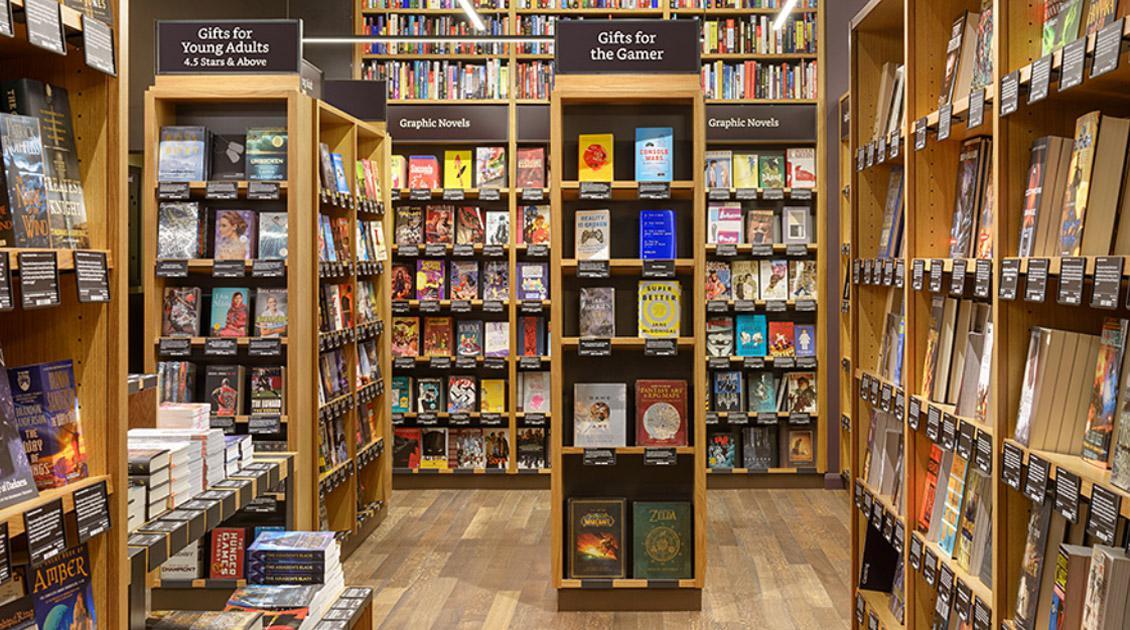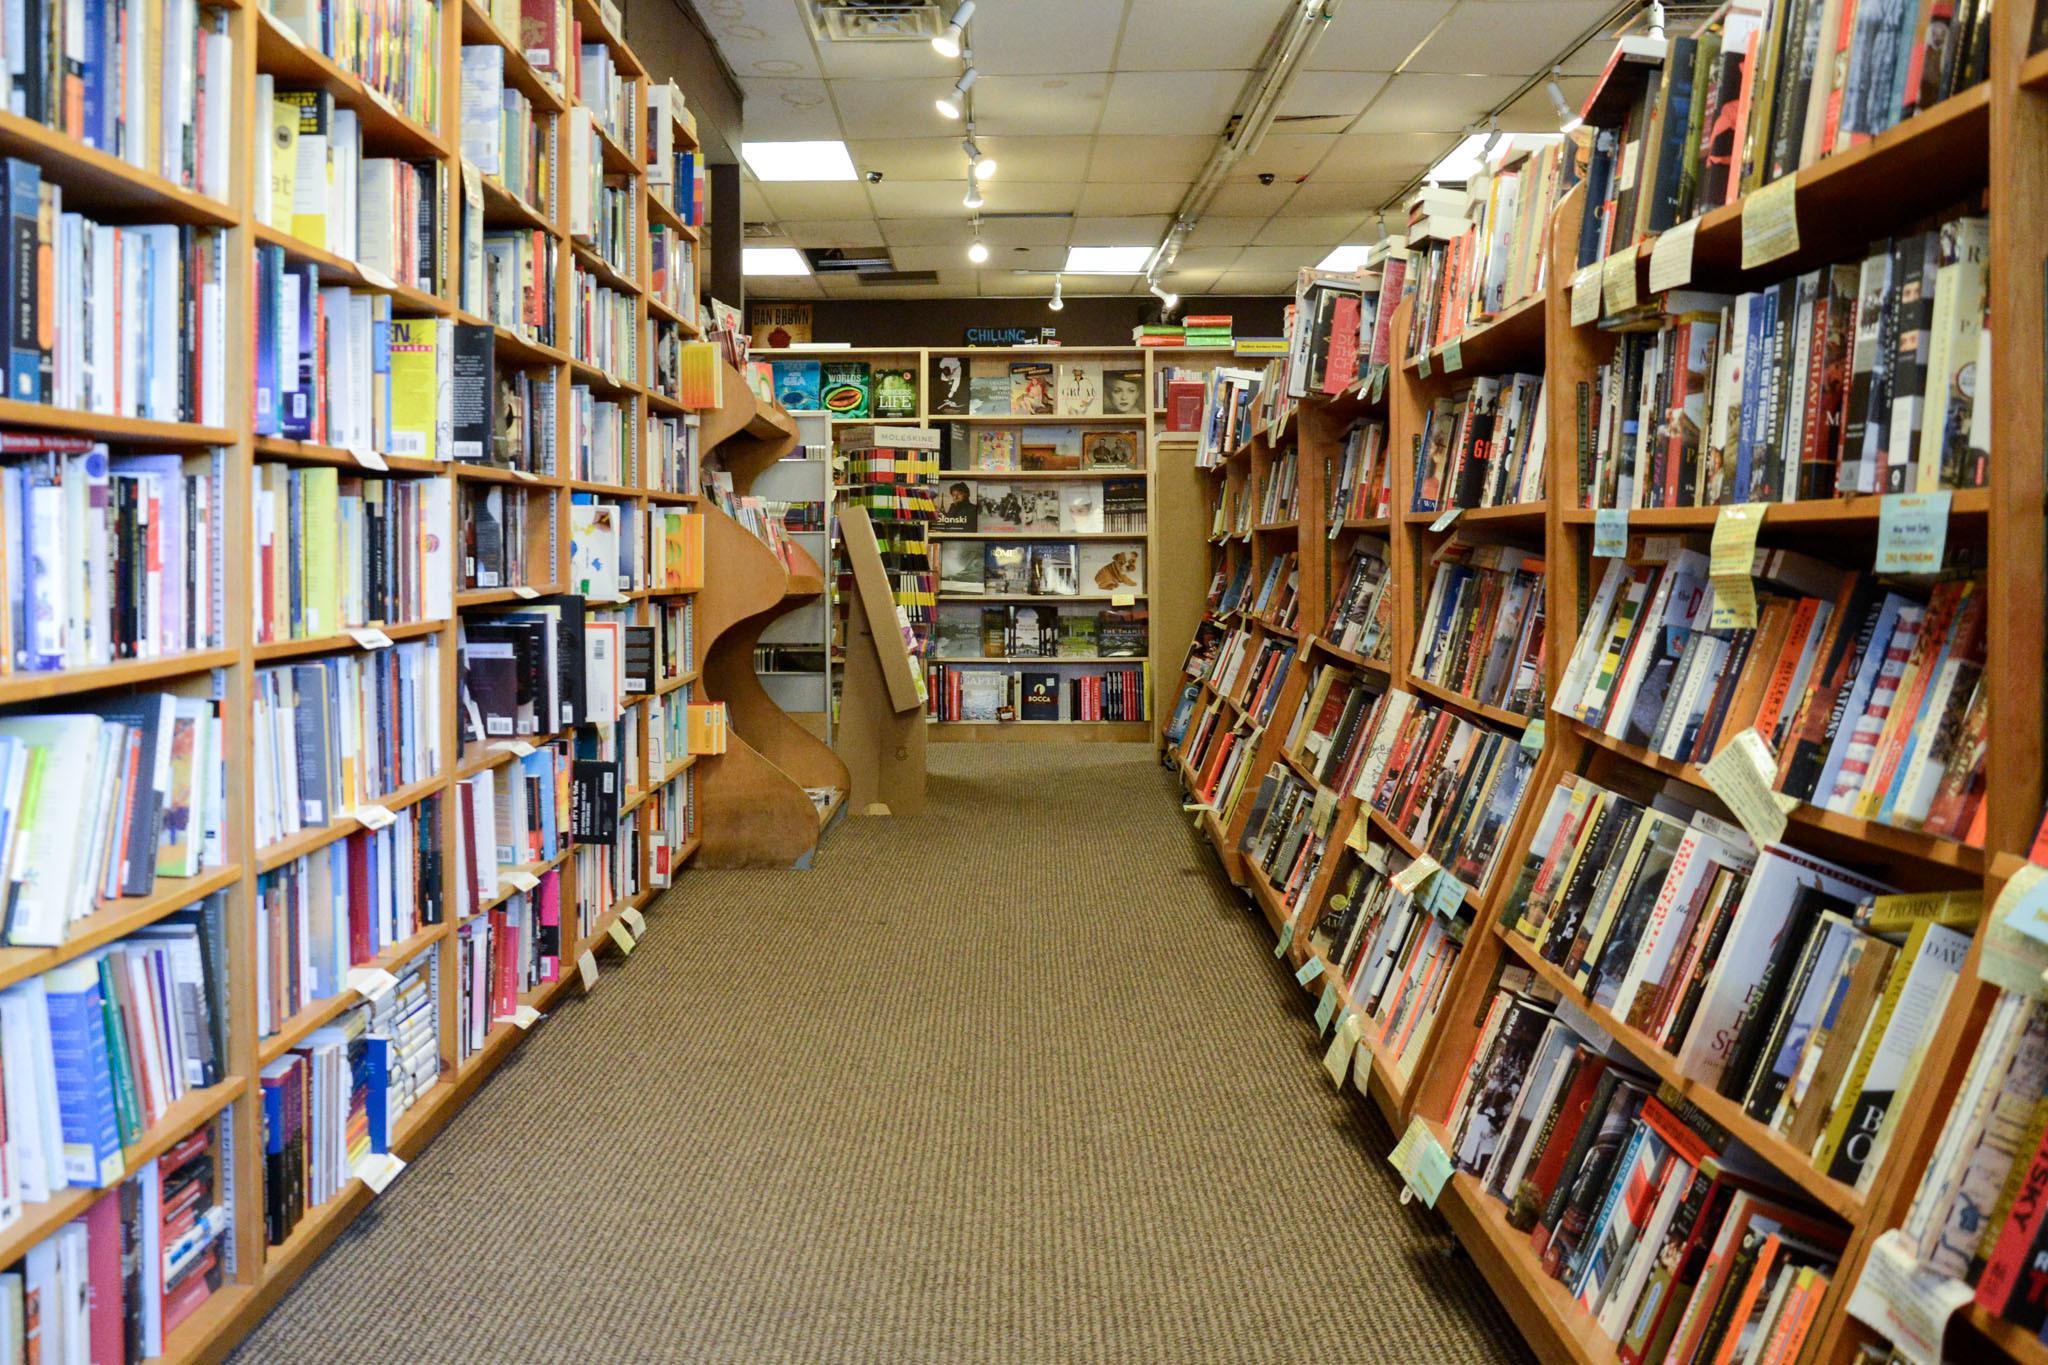The first image is the image on the left, the second image is the image on the right. Given the left and right images, does the statement "In at least one of the images, the source of light is from a track of spotlights on the ceiling." hold true? Answer yes or no. Yes. 